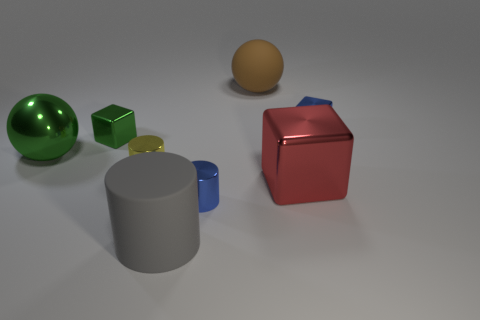What number of other objects are there of the same material as the blue block?
Keep it short and to the point. 5. Is there a red object of the same size as the green metallic sphere?
Offer a very short reply. Yes. There is a brown sphere that is the same size as the matte cylinder; what is it made of?
Provide a succinct answer. Rubber. There is a yellow thing; is its size the same as the blue shiny object to the right of the blue cylinder?
Ensure brevity in your answer.  Yes. How many shiny things are small objects or brown cylinders?
Offer a very short reply. 4. How many big brown rubber things have the same shape as the large gray object?
Make the answer very short. 0. There is a cube that is the same color as the metal sphere; what material is it?
Your answer should be very brief. Metal. There is a matte thing that is behind the yellow shiny cylinder; is its size the same as the shiny block that is to the left of the tiny yellow metallic cylinder?
Your answer should be compact. No. The big shiny thing right of the gray cylinder has what shape?
Offer a terse response. Cube. What material is the other small object that is the same shape as the tiny yellow thing?
Your answer should be compact. Metal. 